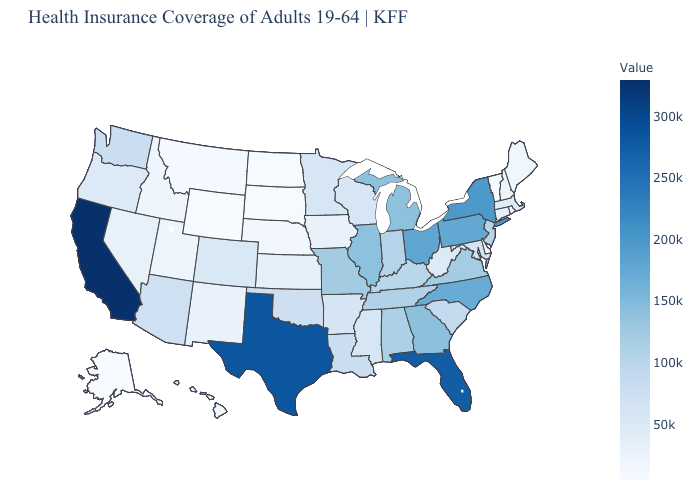Among the states that border Virginia , which have the highest value?
Keep it brief. North Carolina. Which states hav the highest value in the MidWest?
Quick response, please. Ohio. Which states have the highest value in the USA?
Be succinct. California. Is the legend a continuous bar?
Concise answer only. Yes. Which states hav the highest value in the MidWest?
Answer briefly. Ohio. Among the states that border Kansas , does Nebraska have the highest value?
Answer briefly. No. Which states have the highest value in the USA?
Short answer required. California. 